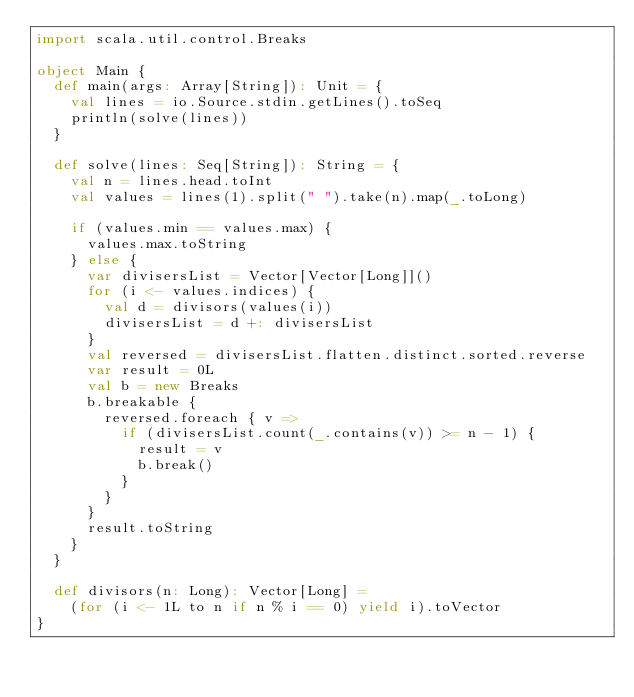<code> <loc_0><loc_0><loc_500><loc_500><_Scala_>import scala.util.control.Breaks

object Main {
  def main(args: Array[String]): Unit = {
    val lines = io.Source.stdin.getLines().toSeq
    println(solve(lines))
  }

  def solve(lines: Seq[String]): String = {
    val n = lines.head.toInt
    val values = lines(1).split(" ").take(n).map(_.toLong)

    if (values.min == values.max) {
      values.max.toString
    } else {
      var divisersList = Vector[Vector[Long]]()
      for (i <- values.indices) {
        val d = divisors(values(i))
        divisersList = d +: divisersList
      }
      val reversed = divisersList.flatten.distinct.sorted.reverse
      var result = 0L
      val b = new Breaks
      b.breakable {
        reversed.foreach { v =>
          if (divisersList.count(_.contains(v)) >= n - 1) {
            result = v
            b.break()
          }
        }
      }
      result.toString
    }
  }

  def divisors(n: Long): Vector[Long] =
    (for (i <- 1L to n if n % i == 0) yield i).toVector
}
</code> 